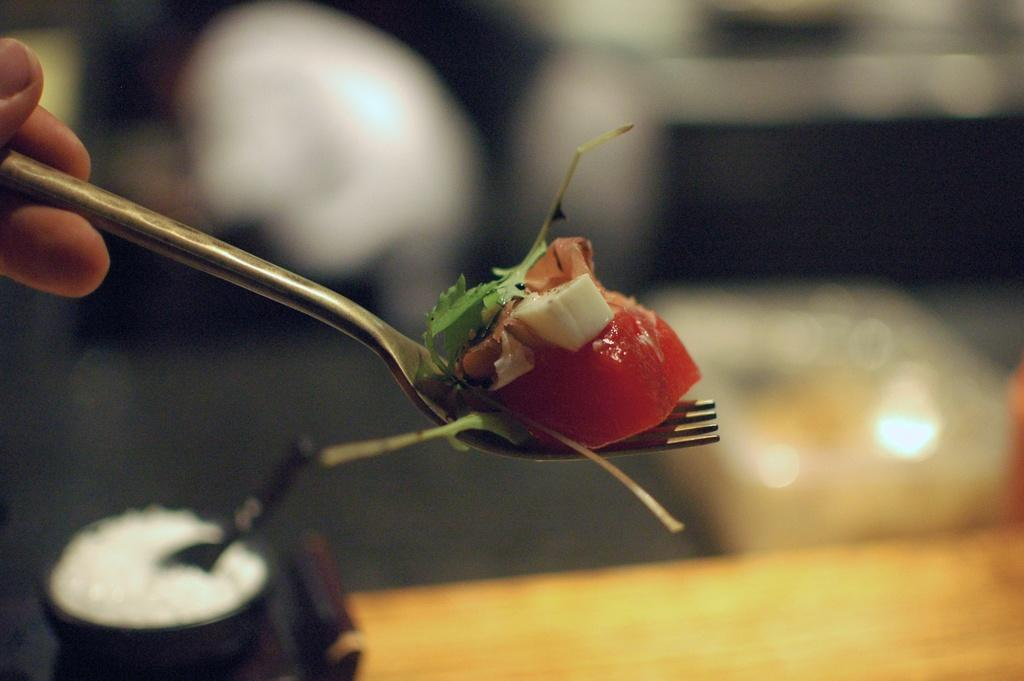What is the person holding in the image? There is a hand holding a fork in the image. What is on the fork? The fork contains food. What piece of furniture is present in the image? There is a table in the image. What else can be seen on the table? There is a bowl with a spoon in the image. What letters are visible on the table in the image? There are no letters visible on the table in the image. What type of room is shown in the image? The image does not show a room; it only shows a hand holding a fork, a table, and a bowl with a spoon. 